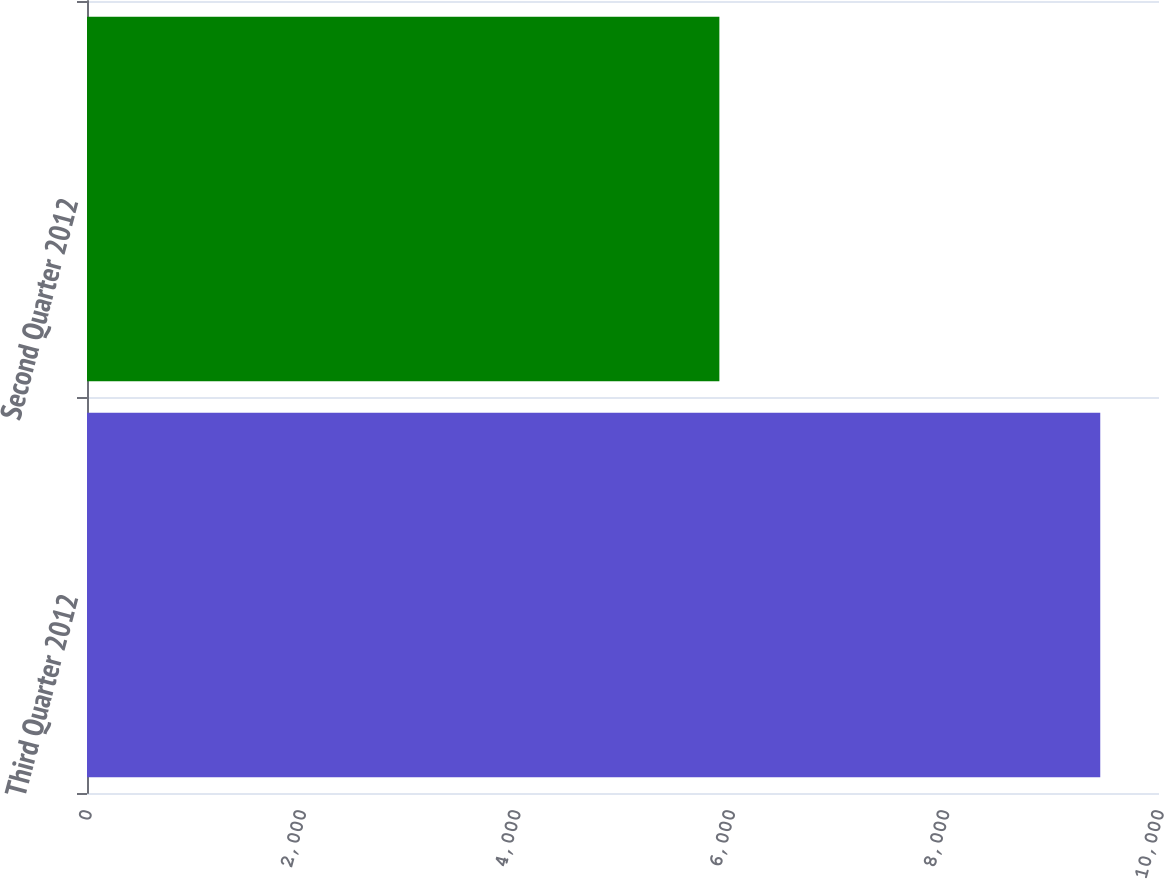<chart> <loc_0><loc_0><loc_500><loc_500><bar_chart><fcel>Third Quarter 2012<fcel>Second Quarter 2012<nl><fcel>9452<fcel>5899<nl></chart> 